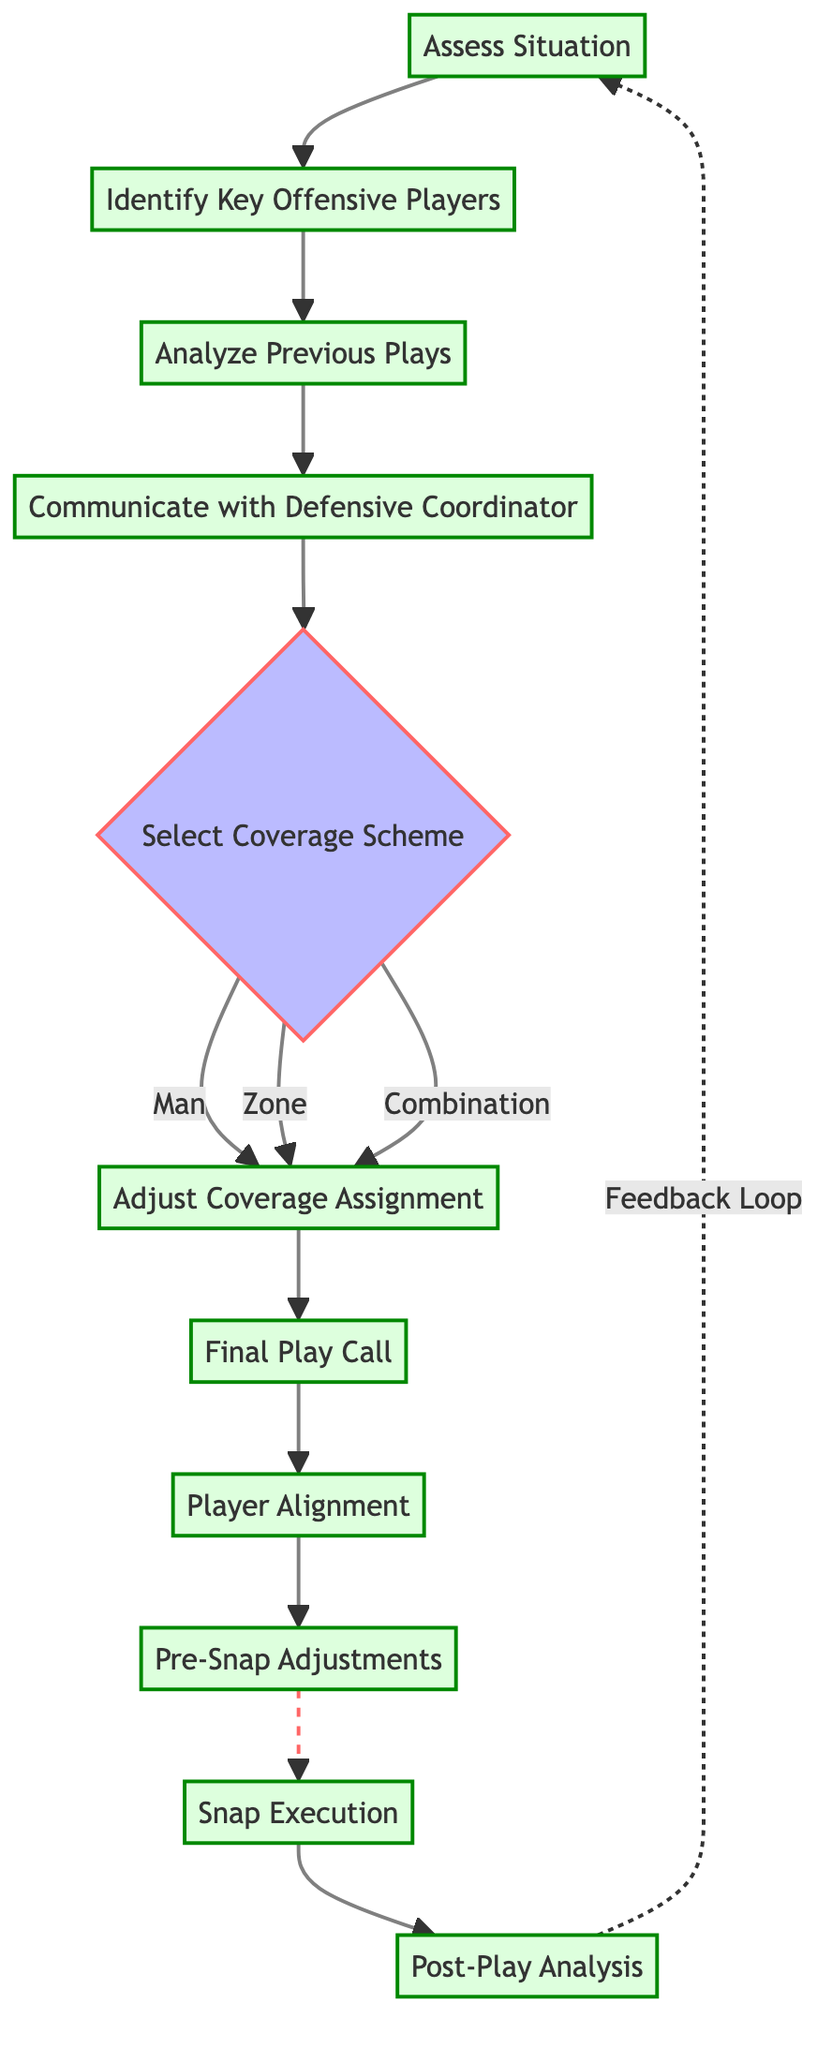What is the first step in the decision-making process? The first step is "Assess Situation" which initiates the flow of the diagram.
Answer: Assess Situation How many total elements are there in the diagram? There are 11 elements listed in the diagram representing the steps in the process.
Answer: 11 What is the final step in the flow chart? The final step indicated in the diagram is "Post-Play Analysis." It is the last node before the feedback loop returns to the beginning.
Answer: Post-Play Analysis Which node follows "Communicate with Defensive Coordinator"? After "Communicate with Defensive Coordinator," the next step in the flow chart is "Select Coverage Scheme."
Answer: Select Coverage Scheme What are the three options presented in the "Select Coverage Scheme" node? The three options are "Man," "Zone," and "Combination," which detail the types of coverage schemes that can be selected.
Answer: Man, Zone, Combination What happens after selecting "Zone" from the "Select Coverage Scheme"? After selecting "Zone," the next action is "Adjust Coverage Assignment," indicating the flow continues to set up based on the chosen scheme.
Answer: Adjust Coverage Assignment Which step involves ensuring positional readiness of defenders? The step that ensures positional readiness is "Player Alignment," where all defenders are positioned correctly for the play.
Answer: Player Alignment What is indicated by the dashed line leading from "Post-Play Analysis" back to "Assess Situation"? The dashed line indicates a feedback loop, suggesting that the analysis after a play informs and impacts future situations and decision-making processes.
Answer: Feedback Loop Which node requires communication and strategy discussion? "Communicate with Defensive Coordinator" is the node dedicated to discussing strategies and seeking feedback from the coordinator about the play call.
Answer: Communicate with Defensive Coordinator 